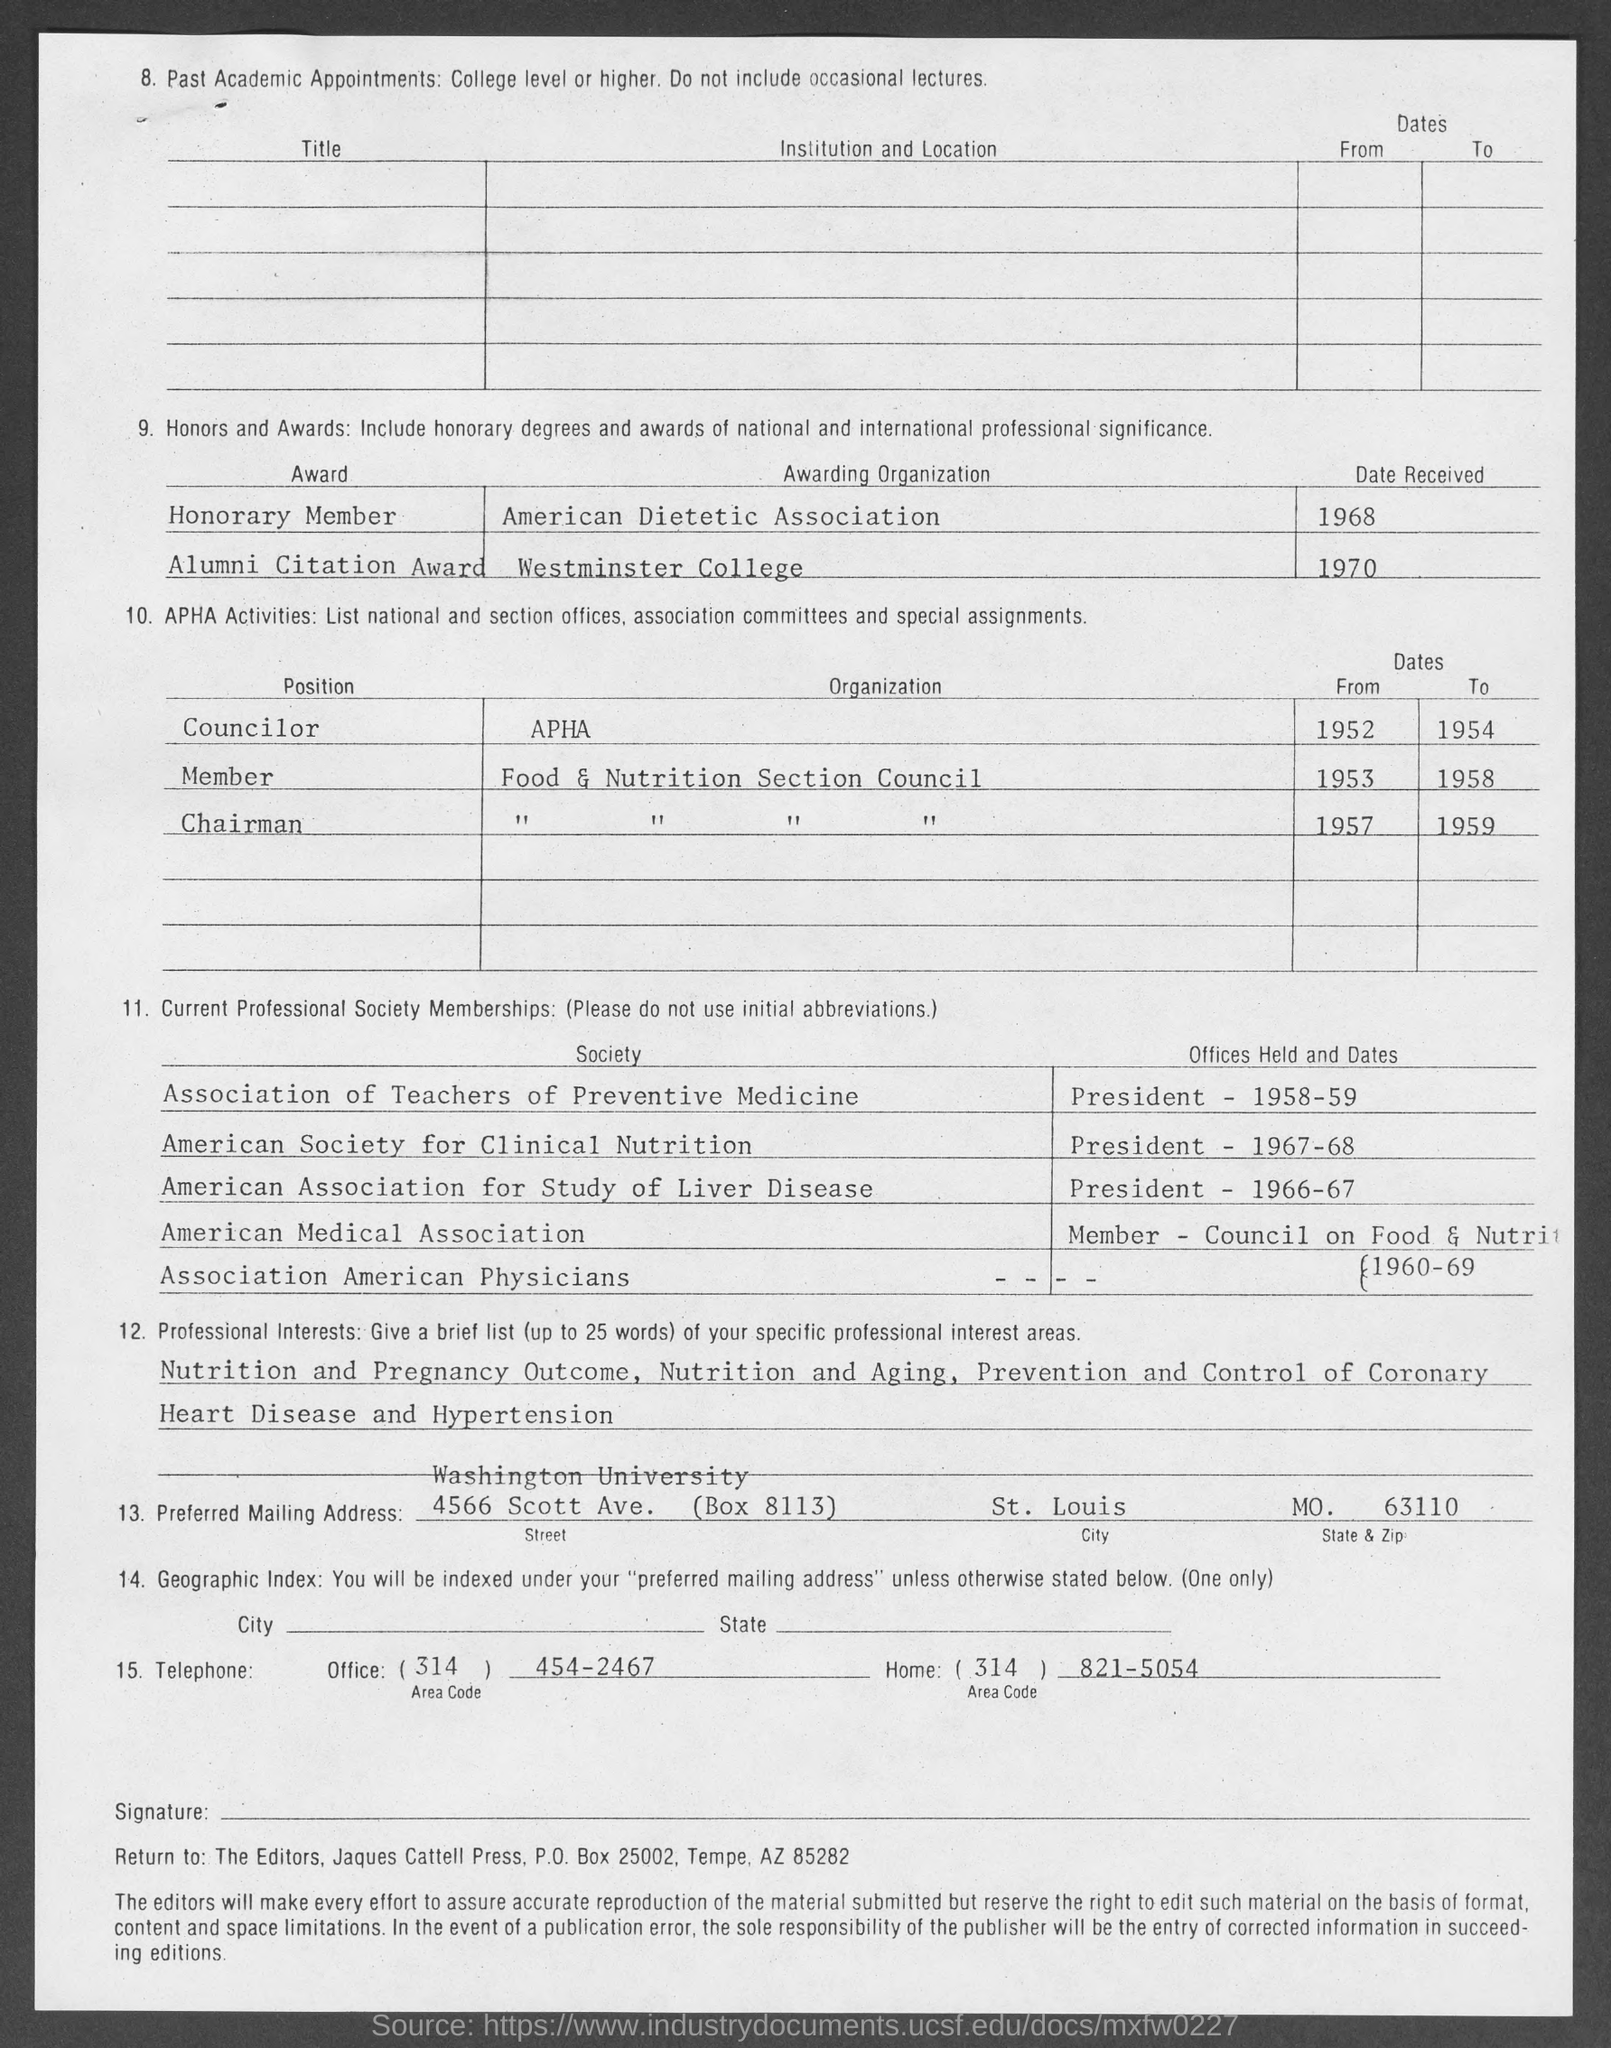What are the awards listed on this document? The awards listed in the document include an 'Honorary Member' from the American Dietetic Association received in 1968 and an 'Alumni Citation Award' from Westminster College received in 1970. These awards recognize the individual's contributions to their field. 